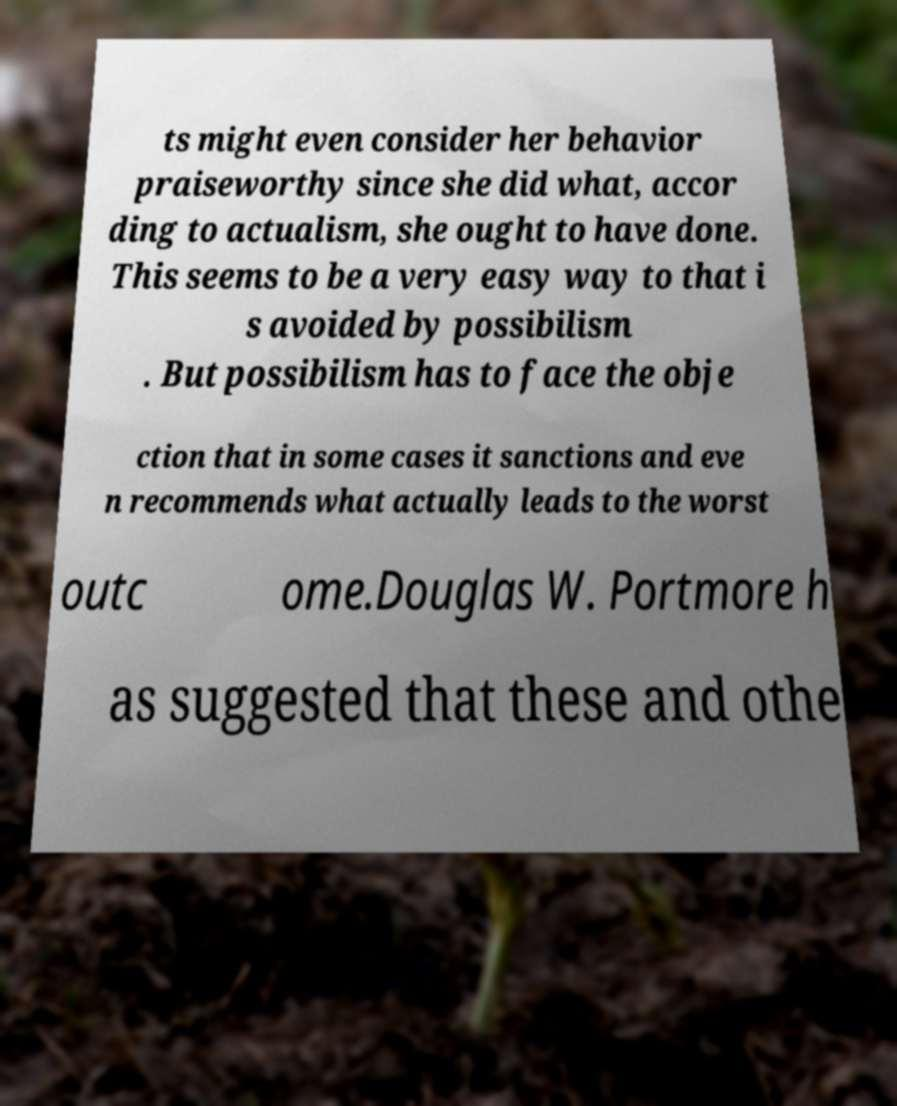I need the written content from this picture converted into text. Can you do that? ts might even consider her behavior praiseworthy since she did what, accor ding to actualism, she ought to have done. This seems to be a very easy way to that i s avoided by possibilism . But possibilism has to face the obje ction that in some cases it sanctions and eve n recommends what actually leads to the worst outc ome.Douglas W. Portmore h as suggested that these and othe 